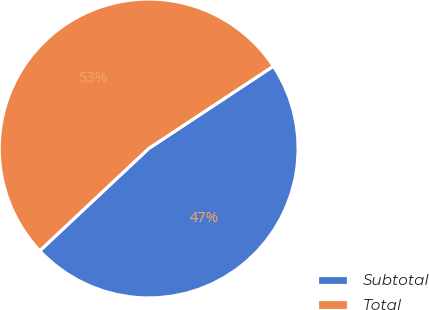Convert chart. <chart><loc_0><loc_0><loc_500><loc_500><pie_chart><fcel>Subtotal<fcel>Total<nl><fcel>47.29%<fcel>52.71%<nl></chart> 